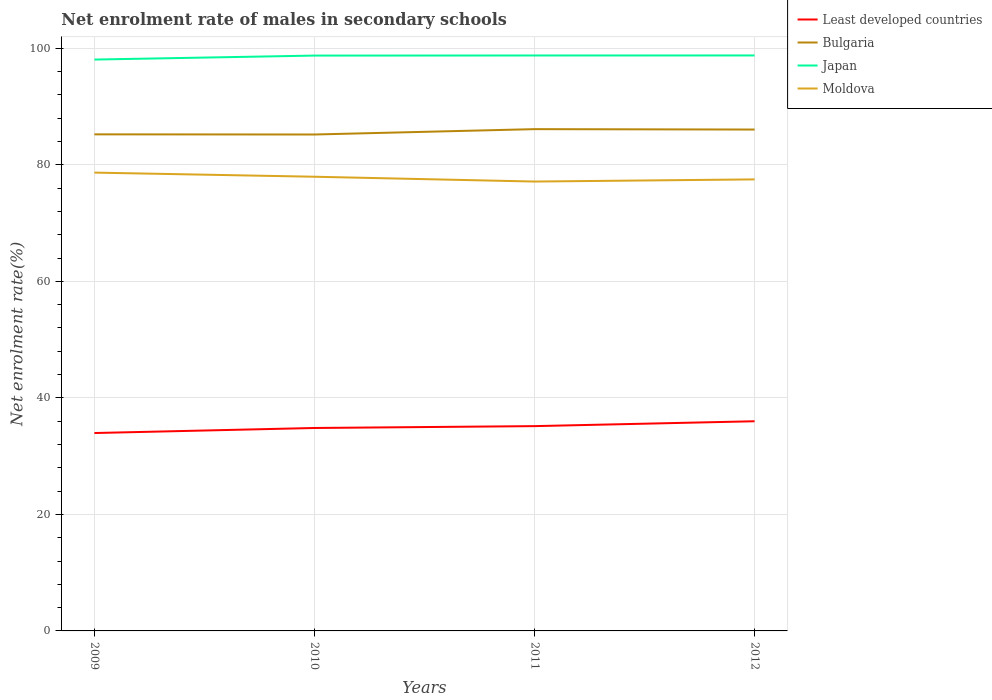How many different coloured lines are there?
Provide a succinct answer. 4. Does the line corresponding to Bulgaria intersect with the line corresponding to Moldova?
Your answer should be compact. No. Is the number of lines equal to the number of legend labels?
Ensure brevity in your answer.  Yes. Across all years, what is the maximum net enrolment rate of males in secondary schools in Least developed countries?
Make the answer very short. 33.97. What is the total net enrolment rate of males in secondary schools in Japan in the graph?
Offer a very short reply. -0.01. What is the difference between the highest and the second highest net enrolment rate of males in secondary schools in Least developed countries?
Provide a succinct answer. 2.02. What is the difference between the highest and the lowest net enrolment rate of males in secondary schools in Moldova?
Offer a very short reply. 2. How many lines are there?
Your answer should be compact. 4. Does the graph contain any zero values?
Offer a very short reply. No. Does the graph contain grids?
Provide a short and direct response. Yes. Where does the legend appear in the graph?
Offer a terse response. Top right. How many legend labels are there?
Your response must be concise. 4. How are the legend labels stacked?
Your response must be concise. Vertical. What is the title of the graph?
Keep it short and to the point. Net enrolment rate of males in secondary schools. What is the label or title of the X-axis?
Keep it short and to the point. Years. What is the label or title of the Y-axis?
Make the answer very short. Net enrolment rate(%). What is the Net enrolment rate(%) in Least developed countries in 2009?
Your answer should be very brief. 33.97. What is the Net enrolment rate(%) in Bulgaria in 2009?
Keep it short and to the point. 85.23. What is the Net enrolment rate(%) in Japan in 2009?
Your response must be concise. 98.07. What is the Net enrolment rate(%) in Moldova in 2009?
Make the answer very short. 78.67. What is the Net enrolment rate(%) of Least developed countries in 2010?
Offer a terse response. 34.83. What is the Net enrolment rate(%) in Bulgaria in 2010?
Your answer should be compact. 85.21. What is the Net enrolment rate(%) in Japan in 2010?
Offer a terse response. 98.76. What is the Net enrolment rate(%) of Moldova in 2010?
Keep it short and to the point. 77.96. What is the Net enrolment rate(%) of Least developed countries in 2011?
Give a very brief answer. 35.15. What is the Net enrolment rate(%) of Bulgaria in 2011?
Give a very brief answer. 86.13. What is the Net enrolment rate(%) in Japan in 2011?
Offer a very short reply. 98.77. What is the Net enrolment rate(%) of Moldova in 2011?
Keep it short and to the point. 77.13. What is the Net enrolment rate(%) of Least developed countries in 2012?
Your answer should be very brief. 35.99. What is the Net enrolment rate(%) in Bulgaria in 2012?
Your answer should be compact. 86.06. What is the Net enrolment rate(%) of Japan in 2012?
Make the answer very short. 98.78. What is the Net enrolment rate(%) in Moldova in 2012?
Your answer should be compact. 77.5. Across all years, what is the maximum Net enrolment rate(%) in Least developed countries?
Ensure brevity in your answer.  35.99. Across all years, what is the maximum Net enrolment rate(%) in Bulgaria?
Provide a short and direct response. 86.13. Across all years, what is the maximum Net enrolment rate(%) of Japan?
Provide a succinct answer. 98.78. Across all years, what is the maximum Net enrolment rate(%) of Moldova?
Provide a short and direct response. 78.67. Across all years, what is the minimum Net enrolment rate(%) of Least developed countries?
Make the answer very short. 33.97. Across all years, what is the minimum Net enrolment rate(%) in Bulgaria?
Provide a short and direct response. 85.21. Across all years, what is the minimum Net enrolment rate(%) in Japan?
Keep it short and to the point. 98.07. Across all years, what is the minimum Net enrolment rate(%) in Moldova?
Your answer should be compact. 77.13. What is the total Net enrolment rate(%) in Least developed countries in the graph?
Keep it short and to the point. 139.94. What is the total Net enrolment rate(%) of Bulgaria in the graph?
Keep it short and to the point. 342.63. What is the total Net enrolment rate(%) of Japan in the graph?
Offer a very short reply. 394.37. What is the total Net enrolment rate(%) in Moldova in the graph?
Provide a succinct answer. 311.26. What is the difference between the Net enrolment rate(%) in Least developed countries in 2009 and that in 2010?
Make the answer very short. -0.87. What is the difference between the Net enrolment rate(%) of Bulgaria in 2009 and that in 2010?
Make the answer very short. 0.02. What is the difference between the Net enrolment rate(%) of Japan in 2009 and that in 2010?
Ensure brevity in your answer.  -0.68. What is the difference between the Net enrolment rate(%) of Moldova in 2009 and that in 2010?
Your answer should be compact. 0.71. What is the difference between the Net enrolment rate(%) of Least developed countries in 2009 and that in 2011?
Provide a short and direct response. -1.19. What is the difference between the Net enrolment rate(%) in Bulgaria in 2009 and that in 2011?
Keep it short and to the point. -0.89. What is the difference between the Net enrolment rate(%) in Japan in 2009 and that in 2011?
Provide a succinct answer. -0.7. What is the difference between the Net enrolment rate(%) in Moldova in 2009 and that in 2011?
Make the answer very short. 1.54. What is the difference between the Net enrolment rate(%) of Least developed countries in 2009 and that in 2012?
Your answer should be compact. -2.02. What is the difference between the Net enrolment rate(%) of Bulgaria in 2009 and that in 2012?
Ensure brevity in your answer.  -0.82. What is the difference between the Net enrolment rate(%) in Japan in 2009 and that in 2012?
Your answer should be compact. -0.7. What is the difference between the Net enrolment rate(%) in Moldova in 2009 and that in 2012?
Your response must be concise. 1.16. What is the difference between the Net enrolment rate(%) in Least developed countries in 2010 and that in 2011?
Offer a terse response. -0.32. What is the difference between the Net enrolment rate(%) of Bulgaria in 2010 and that in 2011?
Ensure brevity in your answer.  -0.92. What is the difference between the Net enrolment rate(%) of Japan in 2010 and that in 2011?
Provide a succinct answer. -0.02. What is the difference between the Net enrolment rate(%) in Moldova in 2010 and that in 2011?
Your answer should be compact. 0.83. What is the difference between the Net enrolment rate(%) in Least developed countries in 2010 and that in 2012?
Offer a terse response. -1.16. What is the difference between the Net enrolment rate(%) in Bulgaria in 2010 and that in 2012?
Make the answer very short. -0.85. What is the difference between the Net enrolment rate(%) in Japan in 2010 and that in 2012?
Provide a succinct answer. -0.02. What is the difference between the Net enrolment rate(%) of Moldova in 2010 and that in 2012?
Keep it short and to the point. 0.46. What is the difference between the Net enrolment rate(%) of Least developed countries in 2011 and that in 2012?
Ensure brevity in your answer.  -0.84. What is the difference between the Net enrolment rate(%) of Bulgaria in 2011 and that in 2012?
Provide a succinct answer. 0.07. What is the difference between the Net enrolment rate(%) of Japan in 2011 and that in 2012?
Make the answer very short. -0.01. What is the difference between the Net enrolment rate(%) of Moldova in 2011 and that in 2012?
Provide a short and direct response. -0.37. What is the difference between the Net enrolment rate(%) in Least developed countries in 2009 and the Net enrolment rate(%) in Bulgaria in 2010?
Keep it short and to the point. -51.24. What is the difference between the Net enrolment rate(%) of Least developed countries in 2009 and the Net enrolment rate(%) of Japan in 2010?
Make the answer very short. -64.79. What is the difference between the Net enrolment rate(%) of Least developed countries in 2009 and the Net enrolment rate(%) of Moldova in 2010?
Your response must be concise. -43.99. What is the difference between the Net enrolment rate(%) of Bulgaria in 2009 and the Net enrolment rate(%) of Japan in 2010?
Provide a succinct answer. -13.52. What is the difference between the Net enrolment rate(%) in Bulgaria in 2009 and the Net enrolment rate(%) in Moldova in 2010?
Offer a terse response. 7.27. What is the difference between the Net enrolment rate(%) of Japan in 2009 and the Net enrolment rate(%) of Moldova in 2010?
Your answer should be very brief. 20.11. What is the difference between the Net enrolment rate(%) of Least developed countries in 2009 and the Net enrolment rate(%) of Bulgaria in 2011?
Provide a short and direct response. -52.16. What is the difference between the Net enrolment rate(%) of Least developed countries in 2009 and the Net enrolment rate(%) of Japan in 2011?
Give a very brief answer. -64.8. What is the difference between the Net enrolment rate(%) of Least developed countries in 2009 and the Net enrolment rate(%) of Moldova in 2011?
Provide a succinct answer. -43.17. What is the difference between the Net enrolment rate(%) of Bulgaria in 2009 and the Net enrolment rate(%) of Japan in 2011?
Make the answer very short. -13.54. What is the difference between the Net enrolment rate(%) in Bulgaria in 2009 and the Net enrolment rate(%) in Moldova in 2011?
Ensure brevity in your answer.  8.1. What is the difference between the Net enrolment rate(%) of Japan in 2009 and the Net enrolment rate(%) of Moldova in 2011?
Your response must be concise. 20.94. What is the difference between the Net enrolment rate(%) in Least developed countries in 2009 and the Net enrolment rate(%) in Bulgaria in 2012?
Ensure brevity in your answer.  -52.09. What is the difference between the Net enrolment rate(%) of Least developed countries in 2009 and the Net enrolment rate(%) of Japan in 2012?
Your response must be concise. -64.81. What is the difference between the Net enrolment rate(%) in Least developed countries in 2009 and the Net enrolment rate(%) in Moldova in 2012?
Provide a short and direct response. -43.54. What is the difference between the Net enrolment rate(%) in Bulgaria in 2009 and the Net enrolment rate(%) in Japan in 2012?
Your response must be concise. -13.54. What is the difference between the Net enrolment rate(%) in Bulgaria in 2009 and the Net enrolment rate(%) in Moldova in 2012?
Keep it short and to the point. 7.73. What is the difference between the Net enrolment rate(%) in Japan in 2009 and the Net enrolment rate(%) in Moldova in 2012?
Offer a terse response. 20.57. What is the difference between the Net enrolment rate(%) of Least developed countries in 2010 and the Net enrolment rate(%) of Bulgaria in 2011?
Your answer should be very brief. -51.3. What is the difference between the Net enrolment rate(%) in Least developed countries in 2010 and the Net enrolment rate(%) in Japan in 2011?
Make the answer very short. -63.94. What is the difference between the Net enrolment rate(%) of Least developed countries in 2010 and the Net enrolment rate(%) of Moldova in 2011?
Offer a terse response. -42.3. What is the difference between the Net enrolment rate(%) of Bulgaria in 2010 and the Net enrolment rate(%) of Japan in 2011?
Provide a succinct answer. -13.56. What is the difference between the Net enrolment rate(%) of Bulgaria in 2010 and the Net enrolment rate(%) of Moldova in 2011?
Provide a succinct answer. 8.08. What is the difference between the Net enrolment rate(%) of Japan in 2010 and the Net enrolment rate(%) of Moldova in 2011?
Ensure brevity in your answer.  21.62. What is the difference between the Net enrolment rate(%) in Least developed countries in 2010 and the Net enrolment rate(%) in Bulgaria in 2012?
Ensure brevity in your answer.  -51.23. What is the difference between the Net enrolment rate(%) in Least developed countries in 2010 and the Net enrolment rate(%) in Japan in 2012?
Offer a terse response. -63.94. What is the difference between the Net enrolment rate(%) of Least developed countries in 2010 and the Net enrolment rate(%) of Moldova in 2012?
Your response must be concise. -42.67. What is the difference between the Net enrolment rate(%) in Bulgaria in 2010 and the Net enrolment rate(%) in Japan in 2012?
Your response must be concise. -13.57. What is the difference between the Net enrolment rate(%) in Bulgaria in 2010 and the Net enrolment rate(%) in Moldova in 2012?
Keep it short and to the point. 7.71. What is the difference between the Net enrolment rate(%) in Japan in 2010 and the Net enrolment rate(%) in Moldova in 2012?
Your answer should be very brief. 21.25. What is the difference between the Net enrolment rate(%) of Least developed countries in 2011 and the Net enrolment rate(%) of Bulgaria in 2012?
Ensure brevity in your answer.  -50.91. What is the difference between the Net enrolment rate(%) in Least developed countries in 2011 and the Net enrolment rate(%) in Japan in 2012?
Your response must be concise. -63.62. What is the difference between the Net enrolment rate(%) in Least developed countries in 2011 and the Net enrolment rate(%) in Moldova in 2012?
Keep it short and to the point. -42.35. What is the difference between the Net enrolment rate(%) of Bulgaria in 2011 and the Net enrolment rate(%) of Japan in 2012?
Provide a succinct answer. -12.65. What is the difference between the Net enrolment rate(%) in Bulgaria in 2011 and the Net enrolment rate(%) in Moldova in 2012?
Offer a very short reply. 8.62. What is the difference between the Net enrolment rate(%) in Japan in 2011 and the Net enrolment rate(%) in Moldova in 2012?
Your response must be concise. 21.27. What is the average Net enrolment rate(%) of Least developed countries per year?
Ensure brevity in your answer.  34.99. What is the average Net enrolment rate(%) of Bulgaria per year?
Offer a very short reply. 85.66. What is the average Net enrolment rate(%) of Japan per year?
Keep it short and to the point. 98.59. What is the average Net enrolment rate(%) of Moldova per year?
Your answer should be very brief. 77.82. In the year 2009, what is the difference between the Net enrolment rate(%) in Least developed countries and Net enrolment rate(%) in Bulgaria?
Your answer should be very brief. -51.27. In the year 2009, what is the difference between the Net enrolment rate(%) in Least developed countries and Net enrolment rate(%) in Japan?
Provide a short and direct response. -64.1. In the year 2009, what is the difference between the Net enrolment rate(%) of Least developed countries and Net enrolment rate(%) of Moldova?
Offer a terse response. -44.7. In the year 2009, what is the difference between the Net enrolment rate(%) of Bulgaria and Net enrolment rate(%) of Japan?
Keep it short and to the point. -12.84. In the year 2009, what is the difference between the Net enrolment rate(%) of Bulgaria and Net enrolment rate(%) of Moldova?
Your answer should be compact. 6.57. In the year 2009, what is the difference between the Net enrolment rate(%) in Japan and Net enrolment rate(%) in Moldova?
Ensure brevity in your answer.  19.4. In the year 2010, what is the difference between the Net enrolment rate(%) in Least developed countries and Net enrolment rate(%) in Bulgaria?
Your answer should be very brief. -50.38. In the year 2010, what is the difference between the Net enrolment rate(%) in Least developed countries and Net enrolment rate(%) in Japan?
Provide a short and direct response. -63.92. In the year 2010, what is the difference between the Net enrolment rate(%) of Least developed countries and Net enrolment rate(%) of Moldova?
Provide a succinct answer. -43.13. In the year 2010, what is the difference between the Net enrolment rate(%) in Bulgaria and Net enrolment rate(%) in Japan?
Offer a terse response. -13.55. In the year 2010, what is the difference between the Net enrolment rate(%) of Bulgaria and Net enrolment rate(%) of Moldova?
Provide a succinct answer. 7.25. In the year 2010, what is the difference between the Net enrolment rate(%) in Japan and Net enrolment rate(%) in Moldova?
Give a very brief answer. 20.8. In the year 2011, what is the difference between the Net enrolment rate(%) in Least developed countries and Net enrolment rate(%) in Bulgaria?
Ensure brevity in your answer.  -50.98. In the year 2011, what is the difference between the Net enrolment rate(%) of Least developed countries and Net enrolment rate(%) of Japan?
Offer a very short reply. -63.62. In the year 2011, what is the difference between the Net enrolment rate(%) of Least developed countries and Net enrolment rate(%) of Moldova?
Offer a very short reply. -41.98. In the year 2011, what is the difference between the Net enrolment rate(%) in Bulgaria and Net enrolment rate(%) in Japan?
Keep it short and to the point. -12.64. In the year 2011, what is the difference between the Net enrolment rate(%) of Bulgaria and Net enrolment rate(%) of Moldova?
Offer a very short reply. 9. In the year 2011, what is the difference between the Net enrolment rate(%) in Japan and Net enrolment rate(%) in Moldova?
Offer a very short reply. 21.64. In the year 2012, what is the difference between the Net enrolment rate(%) in Least developed countries and Net enrolment rate(%) in Bulgaria?
Provide a short and direct response. -50.07. In the year 2012, what is the difference between the Net enrolment rate(%) in Least developed countries and Net enrolment rate(%) in Japan?
Provide a succinct answer. -62.79. In the year 2012, what is the difference between the Net enrolment rate(%) of Least developed countries and Net enrolment rate(%) of Moldova?
Offer a terse response. -41.51. In the year 2012, what is the difference between the Net enrolment rate(%) in Bulgaria and Net enrolment rate(%) in Japan?
Offer a terse response. -12.72. In the year 2012, what is the difference between the Net enrolment rate(%) in Bulgaria and Net enrolment rate(%) in Moldova?
Your answer should be very brief. 8.55. In the year 2012, what is the difference between the Net enrolment rate(%) in Japan and Net enrolment rate(%) in Moldova?
Your response must be concise. 21.27. What is the ratio of the Net enrolment rate(%) in Least developed countries in 2009 to that in 2010?
Offer a very short reply. 0.98. What is the ratio of the Net enrolment rate(%) of Bulgaria in 2009 to that in 2010?
Your response must be concise. 1. What is the ratio of the Net enrolment rate(%) in Japan in 2009 to that in 2010?
Make the answer very short. 0.99. What is the ratio of the Net enrolment rate(%) of Moldova in 2009 to that in 2010?
Offer a very short reply. 1.01. What is the ratio of the Net enrolment rate(%) of Least developed countries in 2009 to that in 2011?
Provide a succinct answer. 0.97. What is the ratio of the Net enrolment rate(%) of Bulgaria in 2009 to that in 2011?
Your response must be concise. 0.99. What is the ratio of the Net enrolment rate(%) of Japan in 2009 to that in 2011?
Your answer should be very brief. 0.99. What is the ratio of the Net enrolment rate(%) in Moldova in 2009 to that in 2011?
Keep it short and to the point. 1.02. What is the ratio of the Net enrolment rate(%) of Least developed countries in 2009 to that in 2012?
Keep it short and to the point. 0.94. What is the ratio of the Net enrolment rate(%) of Least developed countries in 2010 to that in 2011?
Offer a very short reply. 0.99. What is the ratio of the Net enrolment rate(%) in Bulgaria in 2010 to that in 2011?
Provide a short and direct response. 0.99. What is the ratio of the Net enrolment rate(%) of Moldova in 2010 to that in 2011?
Provide a succinct answer. 1.01. What is the ratio of the Net enrolment rate(%) of Least developed countries in 2010 to that in 2012?
Give a very brief answer. 0.97. What is the ratio of the Net enrolment rate(%) in Moldova in 2010 to that in 2012?
Your response must be concise. 1.01. What is the ratio of the Net enrolment rate(%) in Least developed countries in 2011 to that in 2012?
Give a very brief answer. 0.98. What is the ratio of the Net enrolment rate(%) of Bulgaria in 2011 to that in 2012?
Provide a short and direct response. 1. What is the difference between the highest and the second highest Net enrolment rate(%) of Least developed countries?
Provide a succinct answer. 0.84. What is the difference between the highest and the second highest Net enrolment rate(%) of Bulgaria?
Provide a short and direct response. 0.07. What is the difference between the highest and the second highest Net enrolment rate(%) of Japan?
Offer a very short reply. 0.01. What is the difference between the highest and the second highest Net enrolment rate(%) of Moldova?
Your answer should be very brief. 0.71. What is the difference between the highest and the lowest Net enrolment rate(%) in Least developed countries?
Your response must be concise. 2.02. What is the difference between the highest and the lowest Net enrolment rate(%) of Bulgaria?
Your response must be concise. 0.92. What is the difference between the highest and the lowest Net enrolment rate(%) in Japan?
Make the answer very short. 0.7. What is the difference between the highest and the lowest Net enrolment rate(%) of Moldova?
Provide a short and direct response. 1.54. 